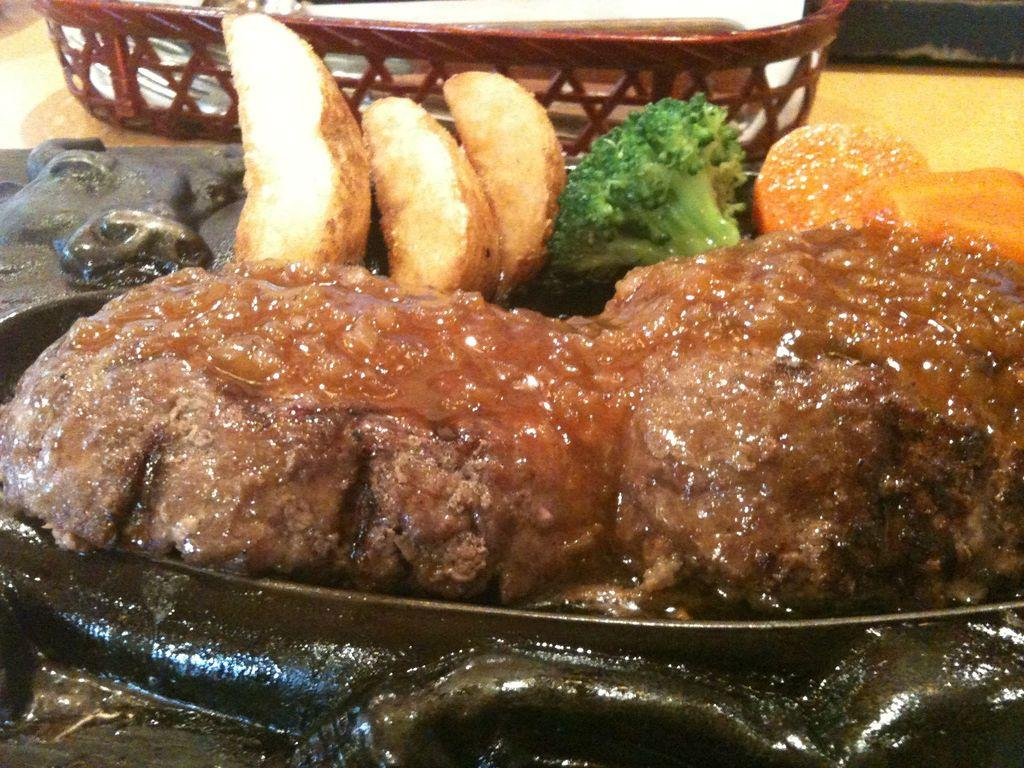What type of food items can be seen in the image? There are cooked food items in the image. Can you identify any specific vegetable in the image? Yes, broccoli is present in the image. How are the food items and broccoli arranged in the image? The food items and broccoli are served on a plate. What type of waste is visible in the image? There is no waste visible in the image; it only shows cooked food items and broccoli served on a plate. 